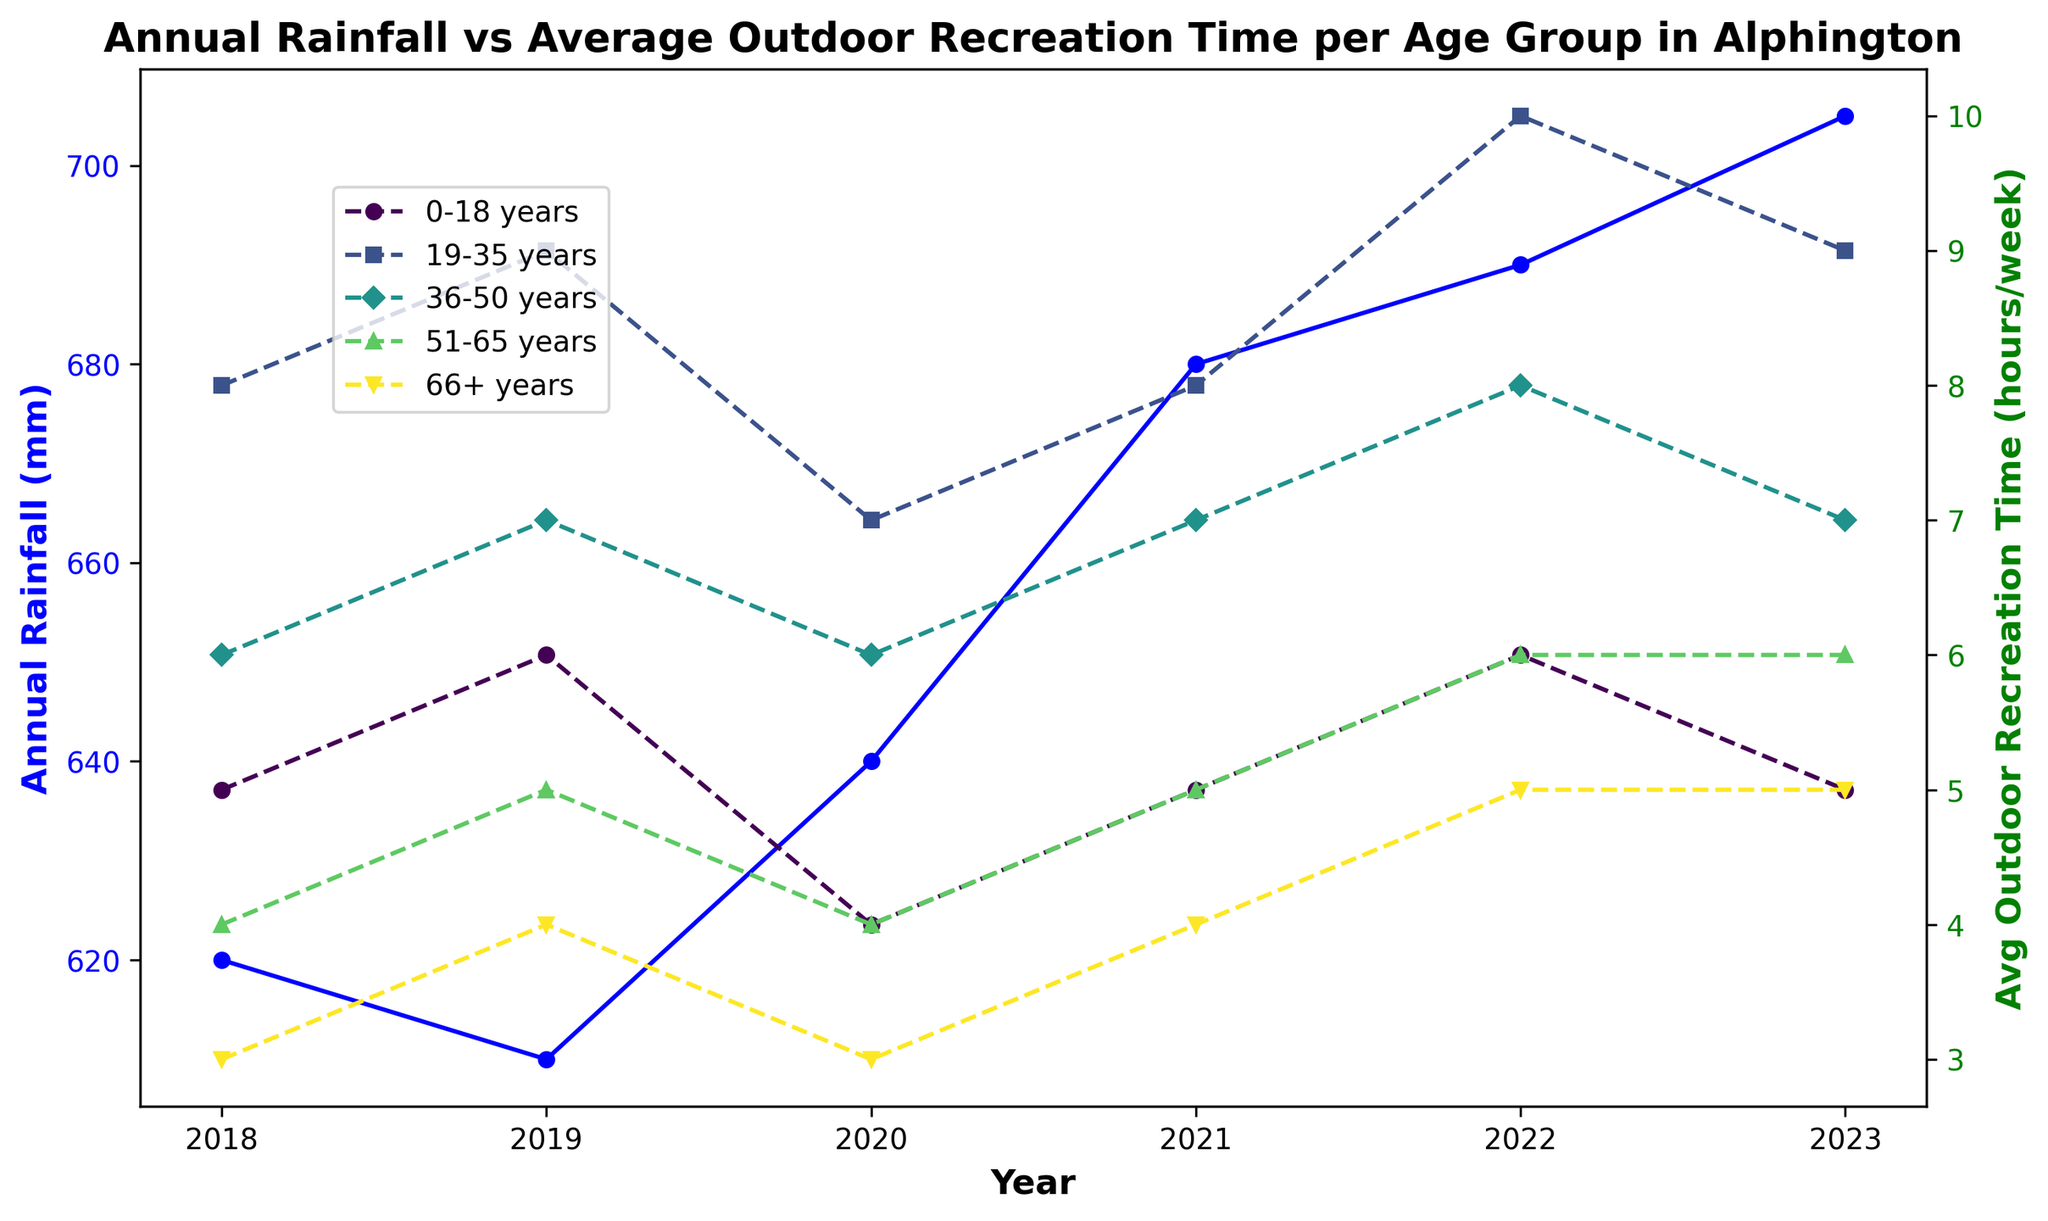What is the trend in annual rainfall from 2018 to 2023? To determine the trend, observe the blue line representing annual rainfall on the left axis across the years from 2018 to 2023. It starts at 620 mm in 2018 and ends at 705 mm in 2023, showing a generally increasing trend.
Answer: Increasing How does the average outdoor recreation time in 2022 for the 36-50 age group compare to that in 2018? To find this, look at the green dashed line with a specific marker for the 36-50 age group. In 2018, it is 6 hours/week, and in 2022, it is 8 hours/week. Compare these two values to see how they change.
Answer: Higher in 2022 Which age group had the highest average outdoor recreation time in 2019? To identify this, observe all the green dashed lines with different markers for 2019. The highest point for this year among the age groups is 9 hours/week, represented by the 19-35 age group.
Answer: 19-35 years What is the combined average outdoor recreation time for the 0-18 and 66+ age groups in 2021? Sum the average outdoor recreation time for the 0-18 (5 hours/week) and 66+ (4 hours/week) age groups in 2021, then divide the sum by 2 to get the combined average. (5 + 4) / 2 = 4.5 hours/week.
Answer: 4.5 hours/week Which year had the highest annual rainfall and by how much did it increase compared to the year with the lowest annual rainfall? Observe the blue line to identify the highest and lowest points. The highest is 705 mm in 2023 and the lowest is 610 mm in 2019. Subtract the lowest from the highest (705 - 610) to find the increase.
Answer: 2023, 95 mm Did any age group have a consistently decreasing average outdoor recreation time from 2018 to 2023? Examine the green dashed lines of each age group from 2018 to 2023. Check if any lines consistently descend. Only the 0-18 age group shows fluctuations, but generally trends lower.
Answer: No How did the average outdoor recreation time for the 66+ age group change between 2018 and 2023? Look at the green dashed line for the 66+ age group. In 2018, it's 3 hours/week, and in 2023, it's 5 hours/week, showing an increase.
Answer: Increased Compare the average outdoor recreation time for the age group 51-65 in 2020 and 2023. Observe the green dashed lines with specific markers for the 51-65 age group. In 2020, it is 4 hours/week, and in 2023, it is 6 hours/week.
Answer: Increased 